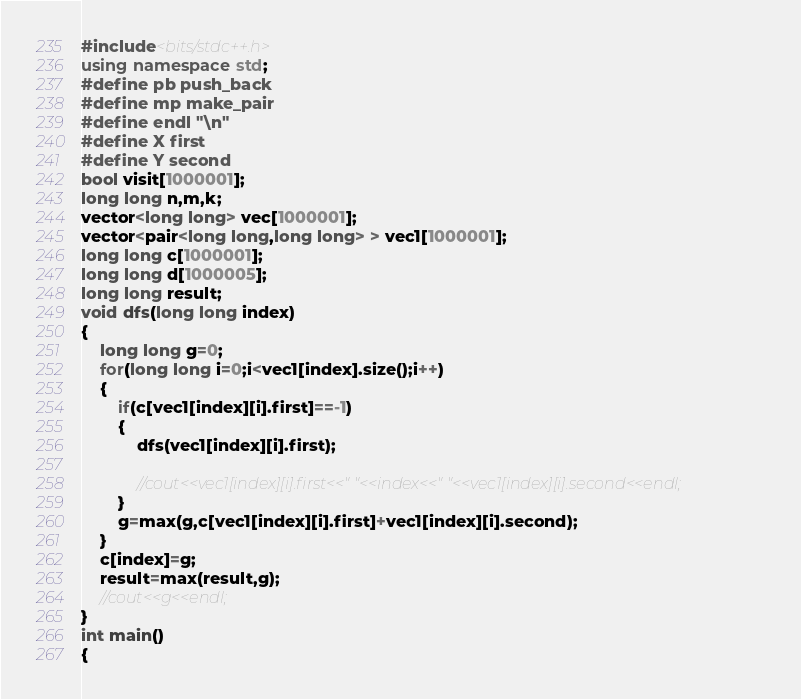Convert code to text. <code><loc_0><loc_0><loc_500><loc_500><_C++_>#include<bits/stdc++.h>
using namespace std;
#define pb push_back
#define mp make_pair
#define endl "\n"
#define X first
#define Y second
bool visit[1000001];
long long n,m,k;
vector<long long> vec[1000001];
vector<pair<long long,long long> > vec1[1000001];
long long c[1000001];
long long d[1000005];
long long result;
void dfs(long long index)
{
	long long g=0;
	for(long long i=0;i<vec1[index].size();i++)
	{
		if(c[vec1[index][i].first]==-1)
		{
			dfs(vec1[index][i].first);
			
			//cout<<vec1[index][i].first<<" "<<index<<" "<<vec1[index][i].second<<endl;
		}
		g=max(g,c[vec1[index][i].first]+vec1[index][i].second);
	}
	c[index]=g;
	result=max(result,g);
	//cout<<g<<endl;
}
int main()
{</code> 